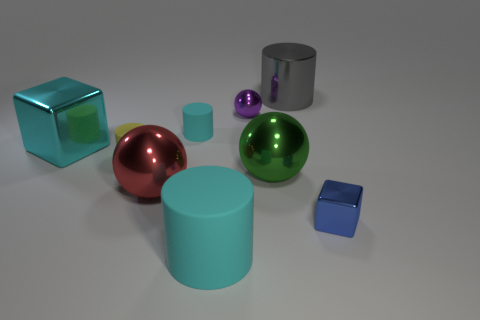Subtract all small purple spheres. How many spheres are left? 2 Subtract all yellow cylinders. How many cylinders are left? 3 Subtract all cylinders. How many objects are left? 5 Add 4 large cubes. How many large cubes are left? 5 Add 5 small gray metal spheres. How many small gray metal spheres exist? 5 Subtract 0 blue balls. How many objects are left? 9 Subtract 2 spheres. How many spheres are left? 1 Subtract all gray cylinders. Subtract all purple balls. How many cylinders are left? 3 Subtract all gray cubes. How many purple balls are left? 1 Subtract all metallic things. Subtract all shiny spheres. How many objects are left? 0 